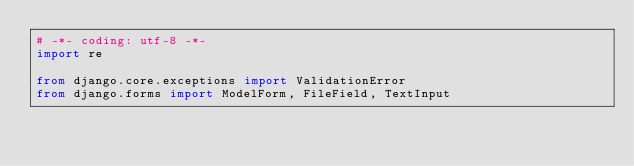<code> <loc_0><loc_0><loc_500><loc_500><_Python_># -*- coding: utf-8 -*-
import re

from django.core.exceptions import ValidationError
from django.forms import ModelForm, FileField, TextInput</code> 